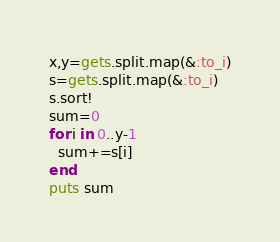Convert code to text. <code><loc_0><loc_0><loc_500><loc_500><_Ruby_>x,y=gets.split.map(&:to_i)
s=gets.split.map(&:to_i)
s.sort!
sum=0
for i in 0..y-1
  sum+=s[i]
end
puts sum
</code> 